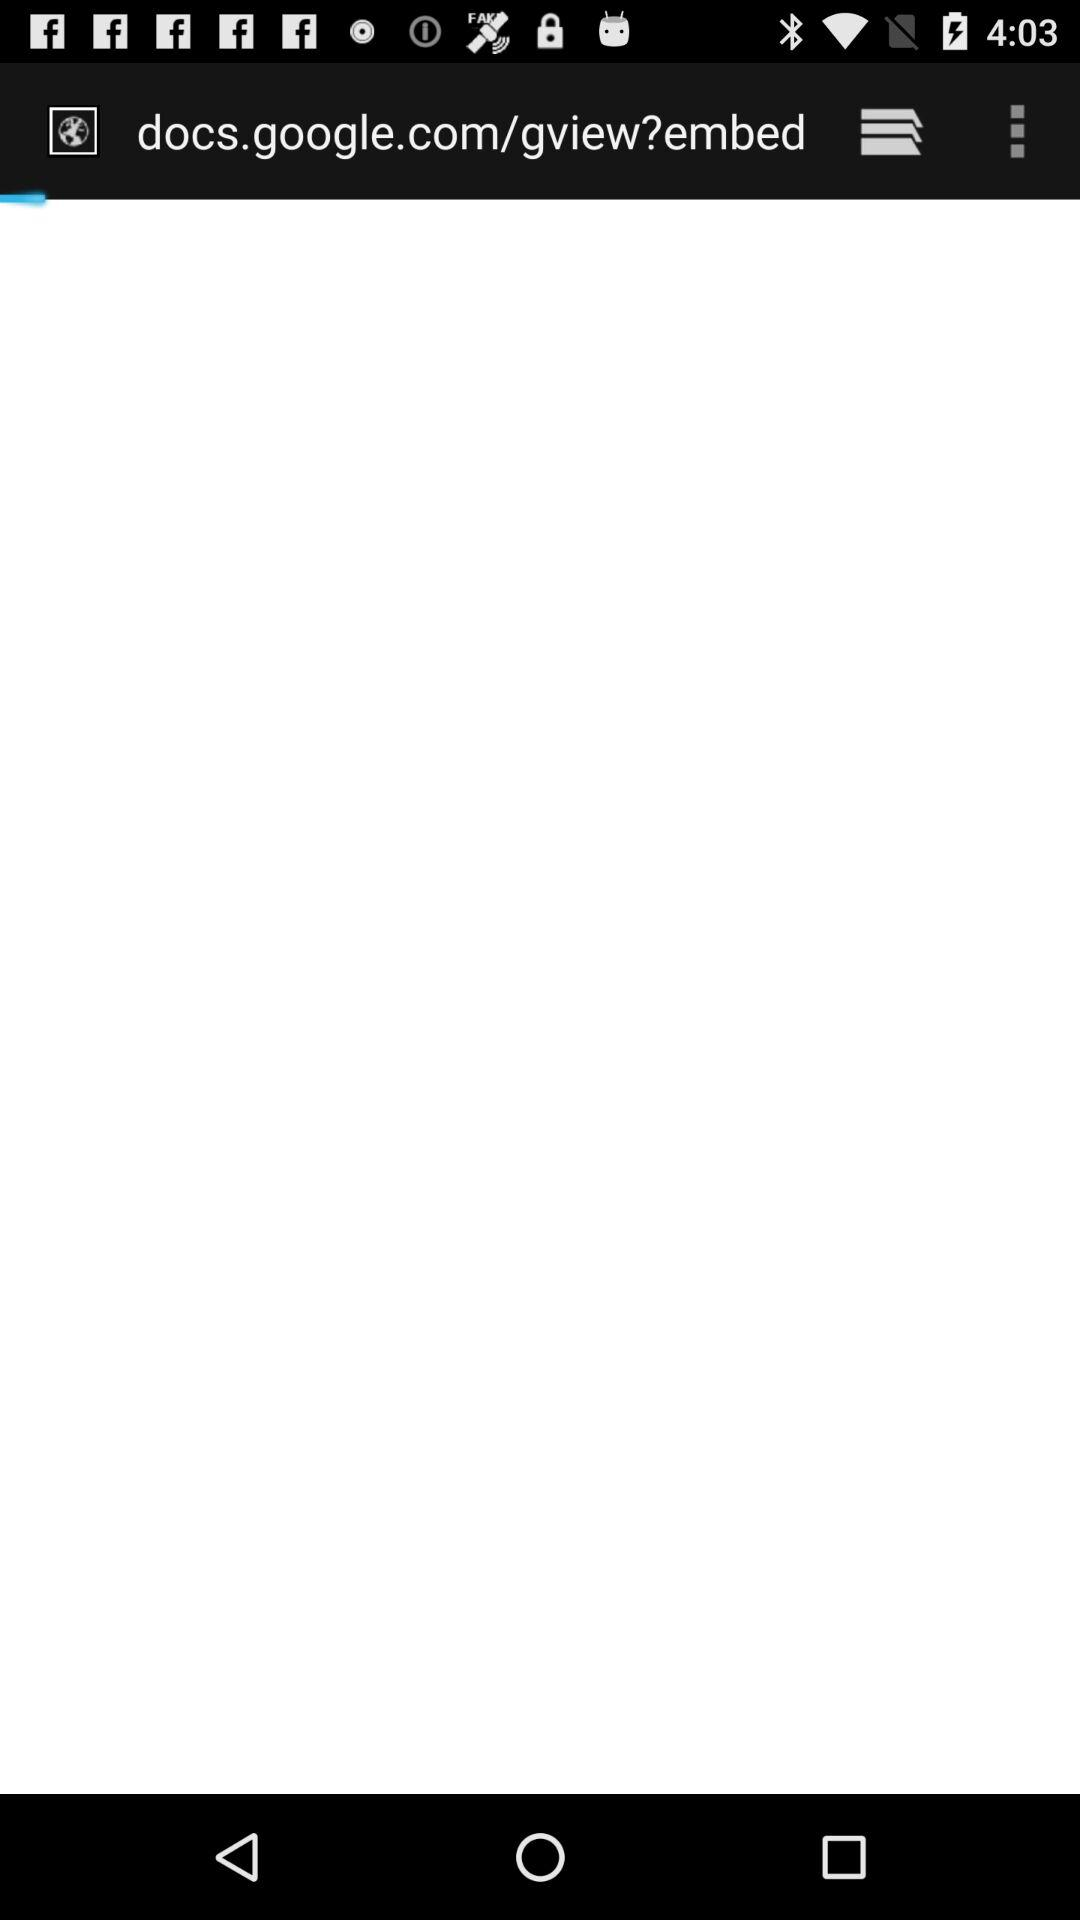Through what application can we log in? You can log in with "Facebook". 